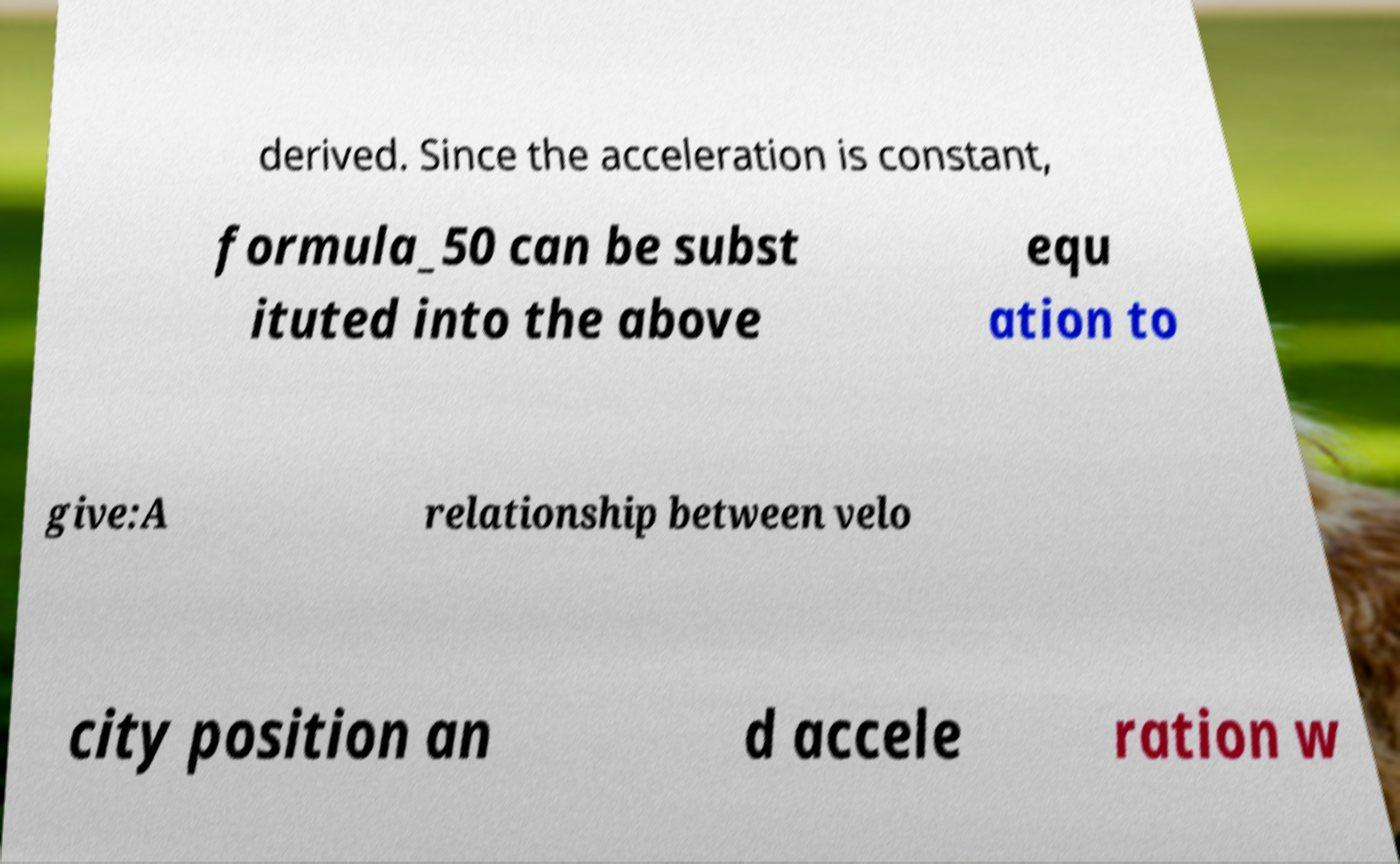Can you accurately transcribe the text from the provided image for me? derived. Since the acceleration is constant, formula_50 can be subst ituted into the above equ ation to give:A relationship between velo city position an d accele ration w 